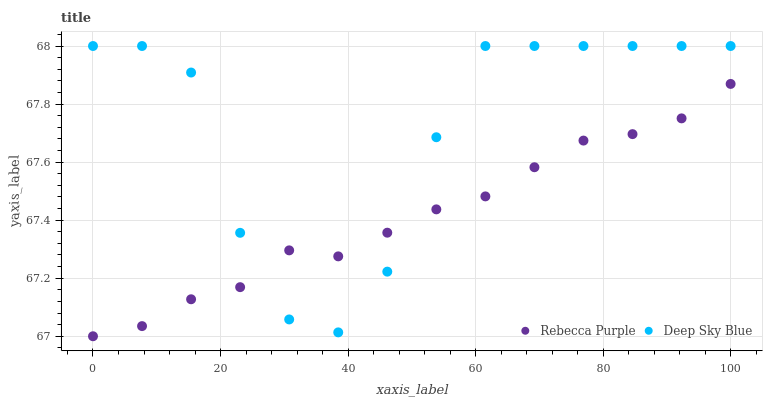Does Rebecca Purple have the minimum area under the curve?
Answer yes or no. Yes. Does Deep Sky Blue have the maximum area under the curve?
Answer yes or no. Yes. Does Deep Sky Blue have the minimum area under the curve?
Answer yes or no. No. Is Rebecca Purple the smoothest?
Answer yes or no. Yes. Is Deep Sky Blue the roughest?
Answer yes or no. Yes. Is Deep Sky Blue the smoothest?
Answer yes or no. No. Does Rebecca Purple have the lowest value?
Answer yes or no. Yes. Does Deep Sky Blue have the lowest value?
Answer yes or no. No. Does Deep Sky Blue have the highest value?
Answer yes or no. Yes. Does Deep Sky Blue intersect Rebecca Purple?
Answer yes or no. Yes. Is Deep Sky Blue less than Rebecca Purple?
Answer yes or no. No. Is Deep Sky Blue greater than Rebecca Purple?
Answer yes or no. No. 